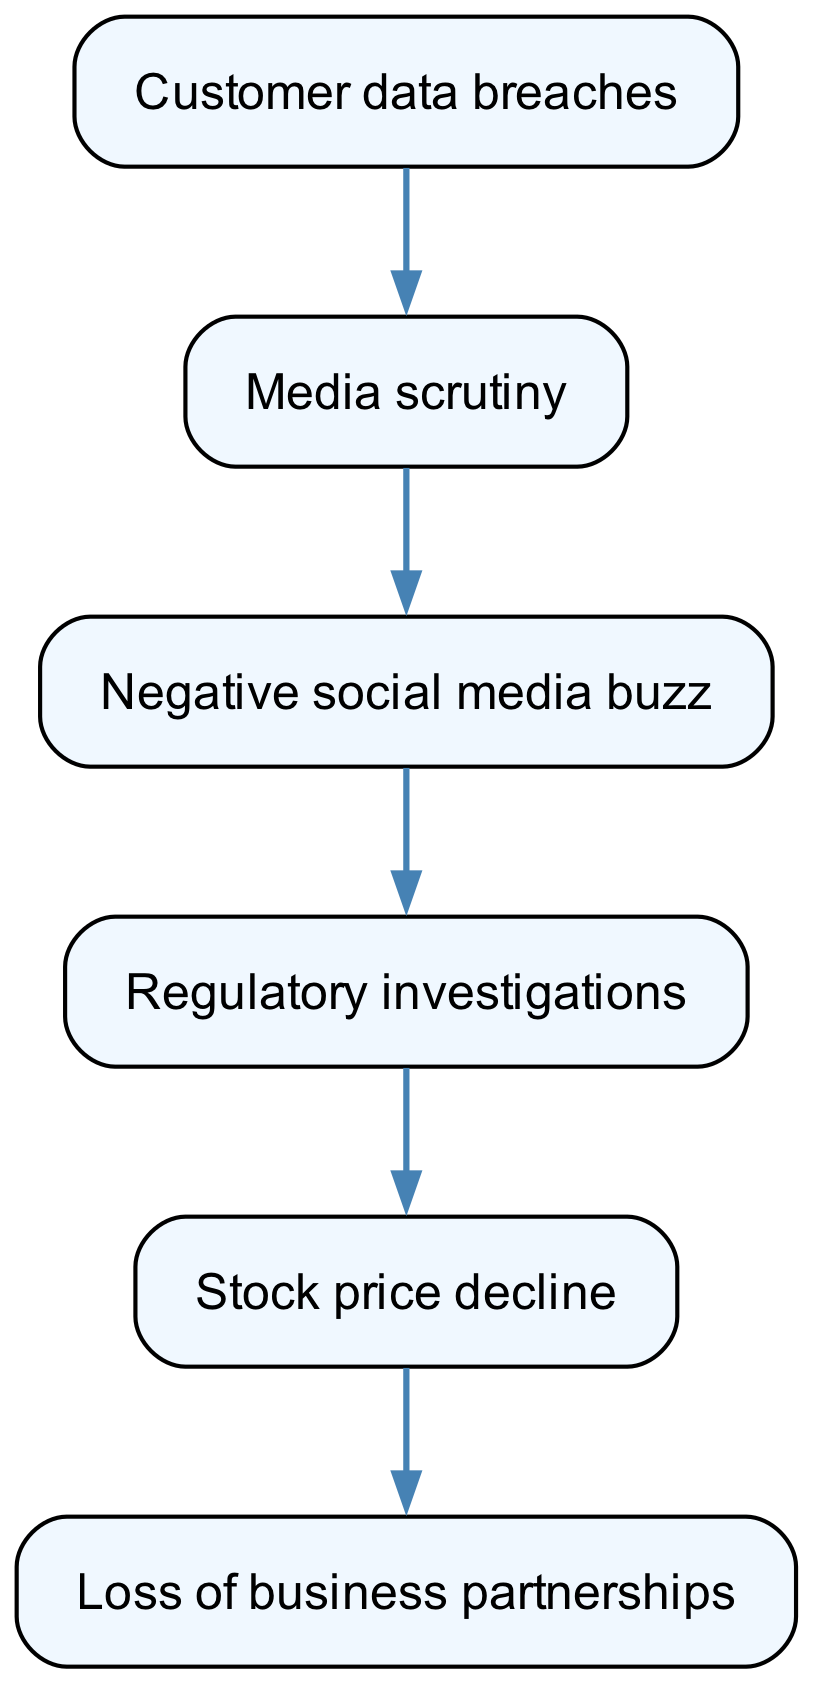What is the first element in the food chain? The first element listed in the diagram is "Customer data breaches," which is represented by the node with ID 2.
Answer: Customer data breaches How many total nodes are there in the diagram? The diagram contains seven elements, including six nodes and one edges container.
Answer: Seven What is the relationship between "Media scrutiny" and "Negative social media buzz"? The diagram shows a directed edge from "Media scrutiny" (ID 1) to "Negative social media buzz" (ID 3), indicating a direct relationship where media scrutiny leads to negative social media buzz.
Answer: Media scrutiny leads to negative social media buzz What follows "Regulatory investigations" in the chain? After "Regulatory investigations" (ID 4), the next element is "Stock price decline" (ID 5) as indicated by the directed edge in the diagram.
Answer: Stock price decline What is the last node in the chain? The final node in the diagram is "Loss of business partnerships," identified as ID 6, which follows the series of events detailed in the chain.
Answer: Loss of business partnerships What type of incidents lead to media scrutiny? The diagram indicates that "Customer data breaches" (ID 2) lead to "Media scrutiny" (ID 1), establishing that these breaches initiate media scrutiny.
Answer: Customer data breaches Which node results directly from negative social media buzz? The directed edge shows that "Negative social media buzz" (ID 3) leads to "Regulatory investigations" (ID 4), indicating that this buzz results in regulatory scrutiny.
Answer: Regulatory investigations How many edges are in the diagram? There are five directed edges connecting the nodes in the diagram, which illustrate the relationships between different elements of the food chain.
Answer: Five What is the overall trend depicted in the food chain? The food chain visually represents a negative trend in stakeholder trust, starting from customer data breaches and leading to a loss of business partnerships, indicating erosion of trust.
Answer: Erosion of trust 